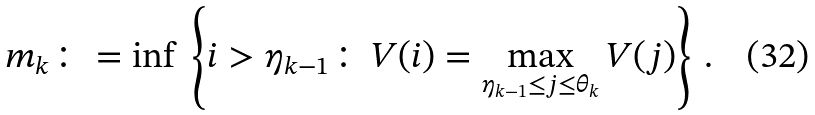Convert formula to latex. <formula><loc_0><loc_0><loc_500><loc_500>m _ { k } \colon = \inf \, \left \{ i > \eta _ { k - 1 } \colon \, V ( i ) = \max _ { \eta _ { k - 1 } \leq j \leq \theta _ { k } } V ( j ) \right \} \, .</formula> 